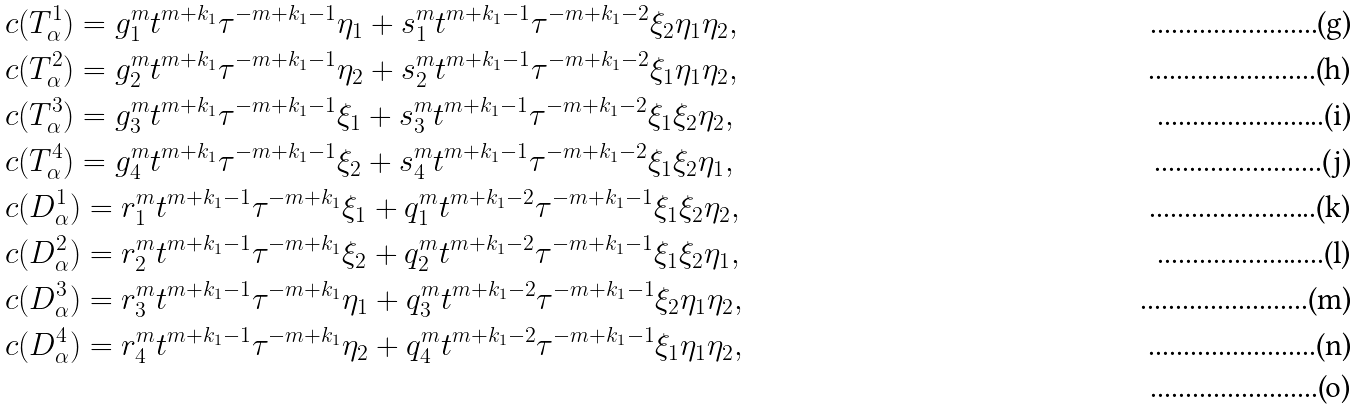<formula> <loc_0><loc_0><loc_500><loc_500>& c ( T _ { \alpha } ^ { 1 } ) = g _ { 1 } ^ { m } t ^ { m + k _ { 1 } } \tau ^ { - m + k _ { 1 } - 1 } \eta _ { 1 } + s _ { 1 } ^ { m } t ^ { m + k _ { 1 } - 1 } \tau ^ { - m + k _ { 1 } - 2 } \xi _ { 2 } \eta _ { 1 } \eta _ { 2 } , \\ & c ( T _ { \alpha } ^ { 2 } ) = g _ { 2 } ^ { m } t ^ { m + k _ { 1 } } \tau ^ { - m + k _ { 1 } - 1 } \eta _ { 2 } + s _ { 2 } ^ { m } t ^ { m + k _ { 1 } - 1 } \tau ^ { - m + k _ { 1 } - 2 } \xi _ { 1 } \eta _ { 1 } \eta _ { 2 } , \\ & c ( T _ { \alpha } ^ { 3 } ) = g _ { 3 } ^ { m } t ^ { m + k _ { 1 } } \tau ^ { - m + k _ { 1 } - 1 } \xi _ { 1 } + s _ { 3 } ^ { m } t ^ { m + k _ { 1 } - 1 } \tau ^ { - m + k _ { 1 } - 2 } \xi _ { 1 } \xi _ { 2 } \eta _ { 2 } , \\ & c ( T _ { \alpha } ^ { 4 } ) = g _ { 4 } ^ { m } t ^ { m + k _ { 1 } } \tau ^ { - m + k _ { 1 } - 1 } \xi _ { 2 } + s _ { 4 } ^ { m } t ^ { m + k _ { 1 } - 1 } \tau ^ { - m + k _ { 1 } - 2 } \xi _ { 1 } \xi _ { 2 } \eta _ { 1 } , \\ & c ( D _ { \alpha } ^ { 1 } ) = r _ { 1 } ^ { m } t ^ { m + k _ { 1 } - 1 } \tau ^ { - m + k _ { 1 } } \xi _ { 1 } + q _ { 1 } ^ { m } t ^ { m + k _ { 1 } - 2 } \tau ^ { - m + k _ { 1 } - 1 } \xi _ { 1 } \xi _ { 2 } \eta _ { 2 } , \\ & c ( D _ { \alpha } ^ { 2 } ) = r _ { 2 } ^ { m } t ^ { m + k _ { 1 } - 1 } \tau ^ { - m + k _ { 1 } } \xi _ { 2 } + q _ { 2 } ^ { m } t ^ { m + k _ { 1 } - 2 } \tau ^ { - m + k _ { 1 } - 1 } \xi _ { 1 } \xi _ { 2 } \eta _ { 1 } , \\ & c ( D _ { \alpha } ^ { 3 } ) = r _ { 3 } ^ { m } t ^ { m + k _ { 1 } - 1 } \tau ^ { - m + k _ { 1 } } \eta _ { 1 } + q _ { 3 } ^ { m } t ^ { m + k _ { 1 } - 2 } \tau ^ { - m + k _ { 1 } - 1 } \xi _ { 2 } \eta _ { 1 } \eta _ { 2 } , \\ & c ( D _ { \alpha } ^ { 4 } ) = r _ { 4 } ^ { m } t ^ { m + k _ { 1 } - 1 } \tau ^ { - m + k _ { 1 } } \eta _ { 2 } + q _ { 4 } ^ { m } t ^ { m + k _ { 1 } - 2 } \tau ^ { - m + k _ { 1 } - 1 } \xi _ { 1 } \eta _ { 1 } \eta _ { 2 } , \\</formula> 